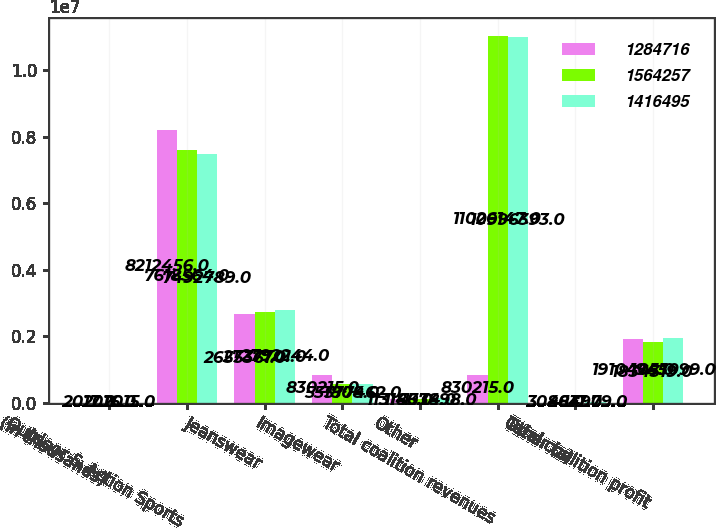Convert chart. <chart><loc_0><loc_0><loc_500><loc_500><stacked_bar_chart><ecel><fcel>(In thousands)<fcel>Outdoor & Action Sports<fcel>Jeanswear<fcel>Imagewear<fcel>Other<fcel>Total coalition revenues<fcel>Other (a)<fcel>Total coalition profit<nl><fcel>1.28472e+06<fcel>2017<fcel>8.21246e+06<fcel>2.65536e+06<fcel>830215<fcel>113145<fcel>830215<fcel>3086<fcel>1.9104e+06<nl><fcel>1.56426e+06<fcel>2016<fcel>7.61856e+06<fcel>2.7377e+06<fcel>551808<fcel>118074<fcel>1.10261e+07<fcel>4817<fcel>1.83432e+06<nl><fcel>1.4165e+06<fcel>2015<fcel>7.49279e+06<fcel>2.79224e+06<fcel>577462<fcel>133898<fcel>1.09964e+07<fcel>14979<fcel>1.9451e+06<nl></chart> 